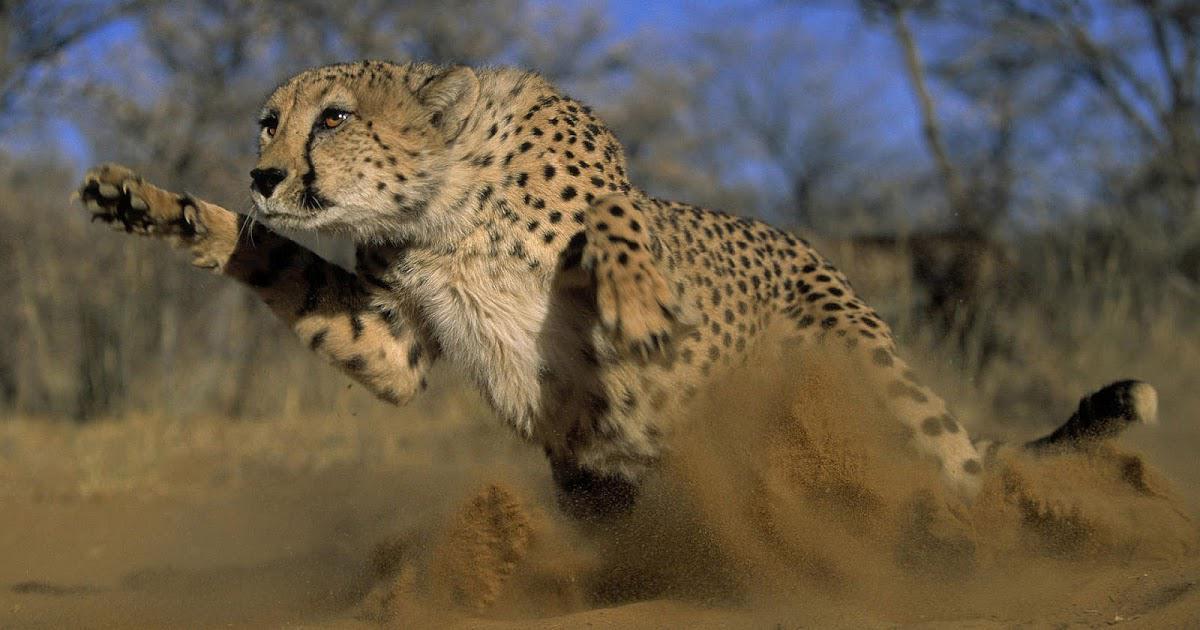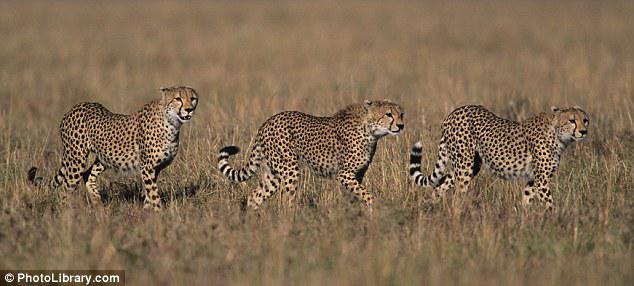The first image is the image on the left, the second image is the image on the right. Evaluate the accuracy of this statement regarding the images: "An image shows one cheetah bounding with front paws extended.". Is it true? Answer yes or no. Yes. The first image is the image on the left, the second image is the image on the right. Analyze the images presented: Is the assertion "There are four cheetas shown" valid? Answer yes or no. Yes. 